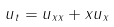Convert formula to latex. <formula><loc_0><loc_0><loc_500><loc_500>u _ { t } = u _ { x x } + x u _ { x }</formula> 